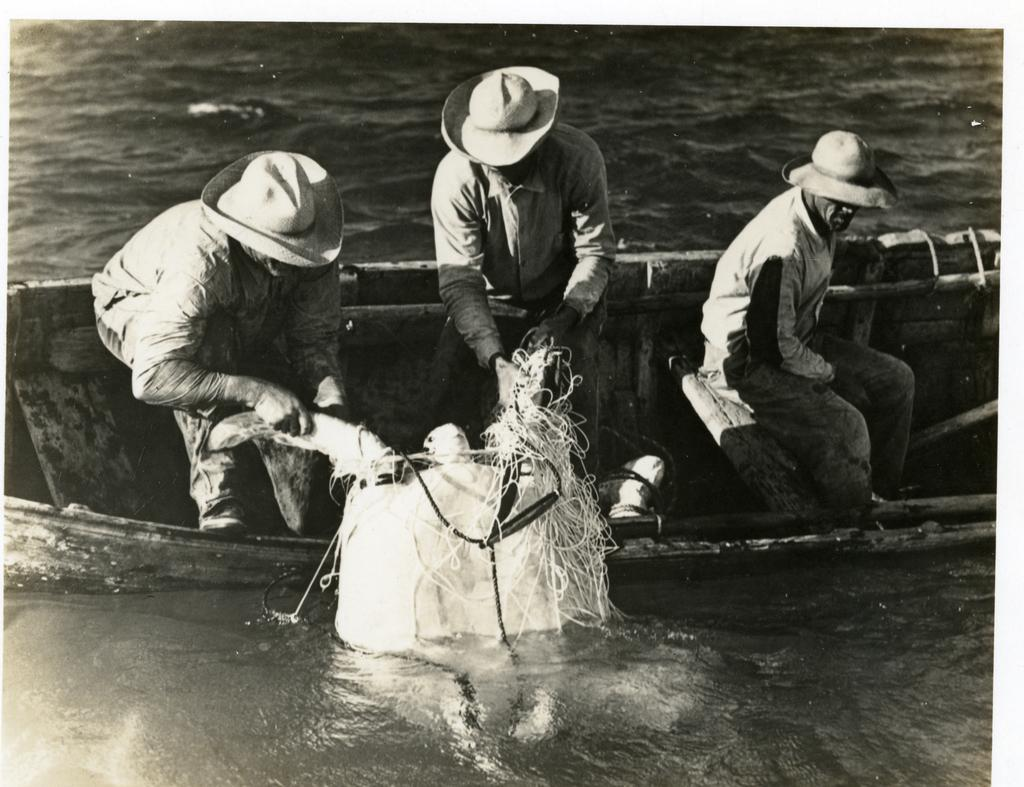What is the main subject of the image? The main subject of the image is a boat. Where is the boat located? The boat is on a lake. How many people are on the boat? There are three persons on the boat. What are the persons wearing? The persons are wearing hats. What are the two persons holding? The two persons are holding an object. What is the weight of the string used to tie the boat to the dock? There is no string or dock mentioned in the image, so it is not possible to determine the weight of a string. 